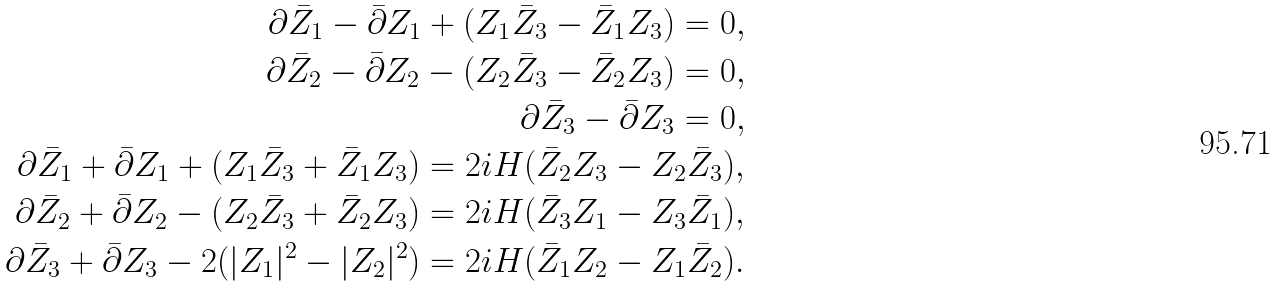<formula> <loc_0><loc_0><loc_500><loc_500>\partial \bar { Z } _ { 1 } - \bar { \partial } Z _ { 1 } + ( Z _ { 1 } \bar { Z } _ { 3 } - \bar { Z } _ { 1 } Z _ { 3 } ) = 0 , \\ \partial \bar { Z } _ { 2 } - \bar { \partial } Z _ { 2 } - ( Z _ { 2 } \bar { Z } _ { 3 } - \bar { Z } _ { 2 } Z _ { 3 } ) = 0 , \\ \partial \bar { Z } _ { 3 } - \bar { \partial } Z _ { 3 } = 0 , \\ \partial \bar { Z } _ { 1 } + \bar { \partial } Z _ { 1 } + ( Z _ { 1 } \bar { Z } _ { 3 } + \bar { Z } _ { 1 } Z _ { 3 } ) = 2 i H ( \bar { Z } _ { 2 } Z _ { 3 } - Z _ { 2 } \bar { Z } _ { 3 } ) , \\ \partial \bar { Z } _ { 2 } + \bar { \partial } Z _ { 2 } - ( Z _ { 2 } \bar { Z } _ { 3 } + \bar { Z } _ { 2 } Z _ { 3 } ) = 2 i H ( \bar { Z } _ { 3 } Z _ { 1 } - Z _ { 3 } \bar { Z } _ { 1 } ) , \\ \partial \bar { Z } _ { 3 } + \bar { \partial } Z _ { 3 } - 2 ( | Z _ { 1 } | ^ { 2 } - | Z _ { 2 } | ^ { 2 } ) = 2 i H ( \bar { Z } _ { 1 } Z _ { 2 } - Z _ { 1 } \bar { Z } _ { 2 } ) .</formula> 